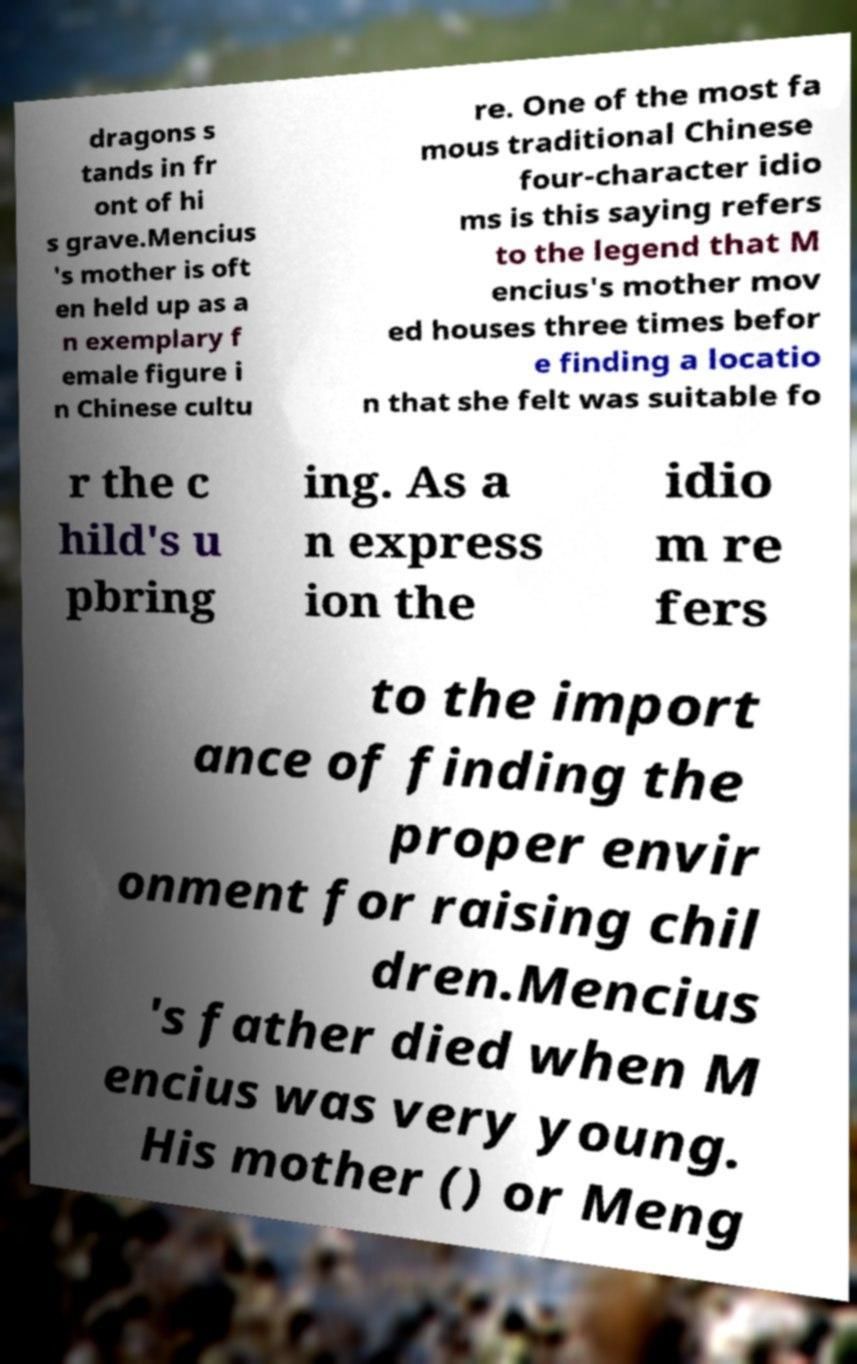Can you read and provide the text displayed in the image?This photo seems to have some interesting text. Can you extract and type it out for me? dragons s tands in fr ont of hi s grave.Mencius 's mother is oft en held up as a n exemplary f emale figure i n Chinese cultu re. One of the most fa mous traditional Chinese four-character idio ms is this saying refers to the legend that M encius's mother mov ed houses three times befor e finding a locatio n that she felt was suitable fo r the c hild's u pbring ing. As a n express ion the idio m re fers to the import ance of finding the proper envir onment for raising chil dren.Mencius 's father died when M encius was very young. His mother () or Meng 